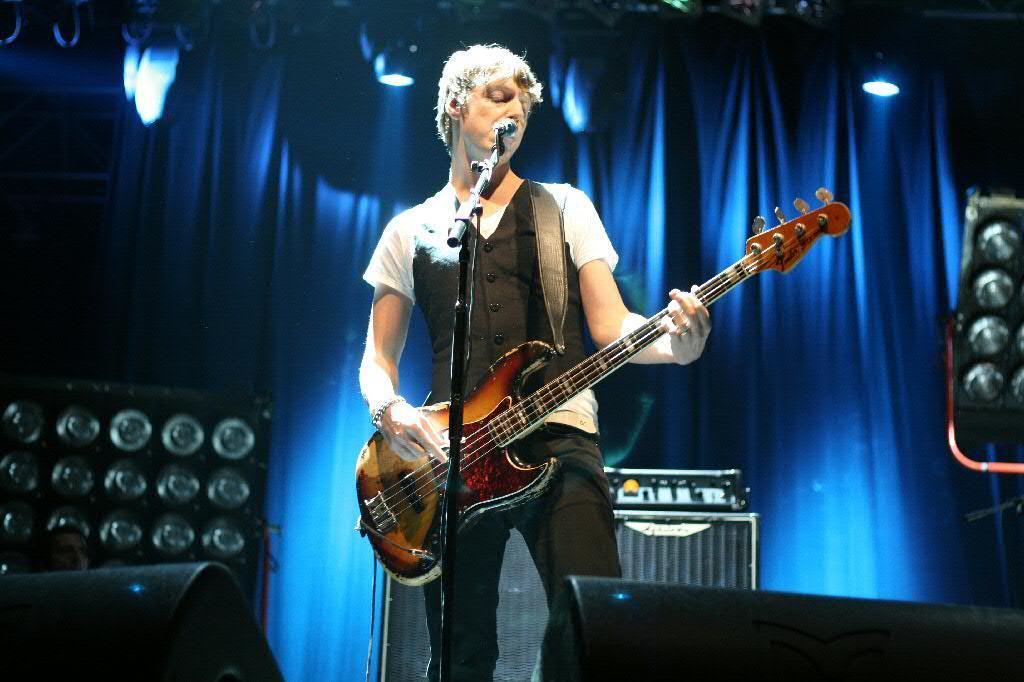What is the man in the image doing? The man is playing the guitar and singing on a microphone. What instrument is the man holding in the image? The man is holding a guitar in the image. What can be seen in the background of the image? There are curtains, speakers, and lights in the image. What type of disease is the man suffering from in the image? There is no indication in the image that the man is suffering from any disease. Can you tell me how to get to the nearest train station using the map in the image? There is no map present in the image. 